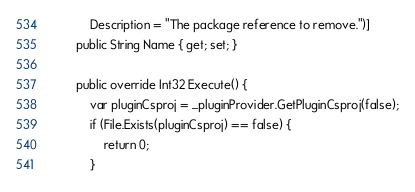<code> <loc_0><loc_0><loc_500><loc_500><_C#_>            Description = "The package reference to remove.")]
        public String Name { get; set; }

        public override Int32 Execute() {
            var pluginCsproj = _pluginProvider.GetPluginCsproj(false);
            if (File.Exists(pluginCsproj) == false) {
                return 0;
            }
</code> 